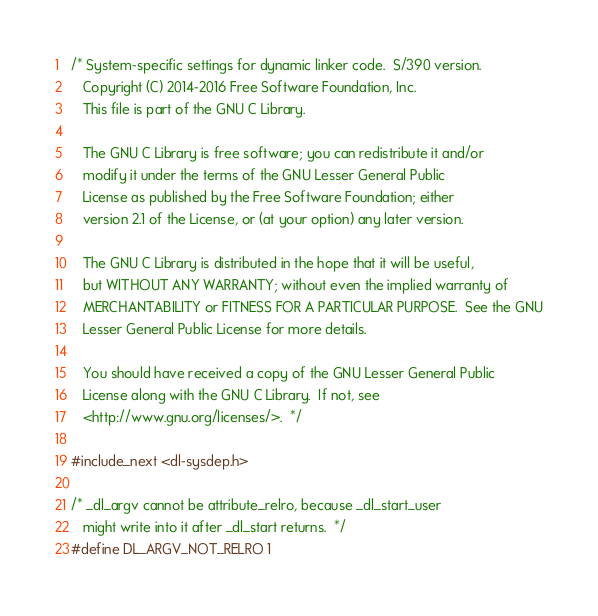<code> <loc_0><loc_0><loc_500><loc_500><_C_>/* System-specific settings for dynamic linker code.  S/390 version.
   Copyright (C) 2014-2016 Free Software Foundation, Inc.
   This file is part of the GNU C Library.

   The GNU C Library is free software; you can redistribute it and/or
   modify it under the terms of the GNU Lesser General Public
   License as published by the Free Software Foundation; either
   version 2.1 of the License, or (at your option) any later version.

   The GNU C Library is distributed in the hope that it will be useful,
   but WITHOUT ANY WARRANTY; without even the implied warranty of
   MERCHANTABILITY or FITNESS FOR A PARTICULAR PURPOSE.  See the GNU
   Lesser General Public License for more details.

   You should have received a copy of the GNU Lesser General Public
   License along with the GNU C Library.  If not, see
   <http://www.gnu.org/licenses/>.  */

#include_next <dl-sysdep.h>

/* _dl_argv cannot be attribute_relro, because _dl_start_user
   might write into it after _dl_start returns.  */
#define DL_ARGV_NOT_RELRO 1
</code> 